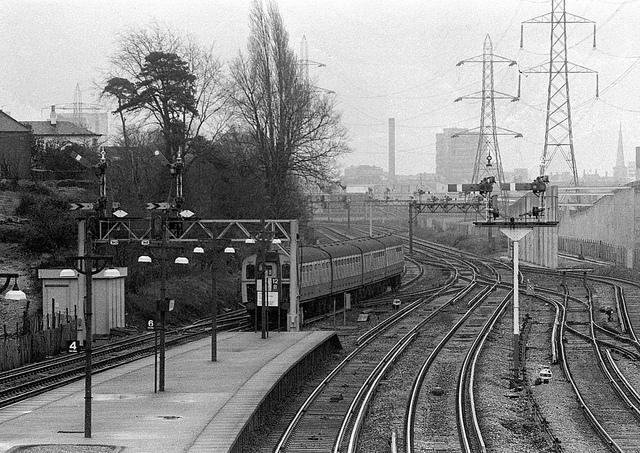How many trains are on the track?
Short answer required. 1. How many power poles are off in the distance?
Short answer required. 2. Where is the photo taken?
Write a very short answer. Train station. 